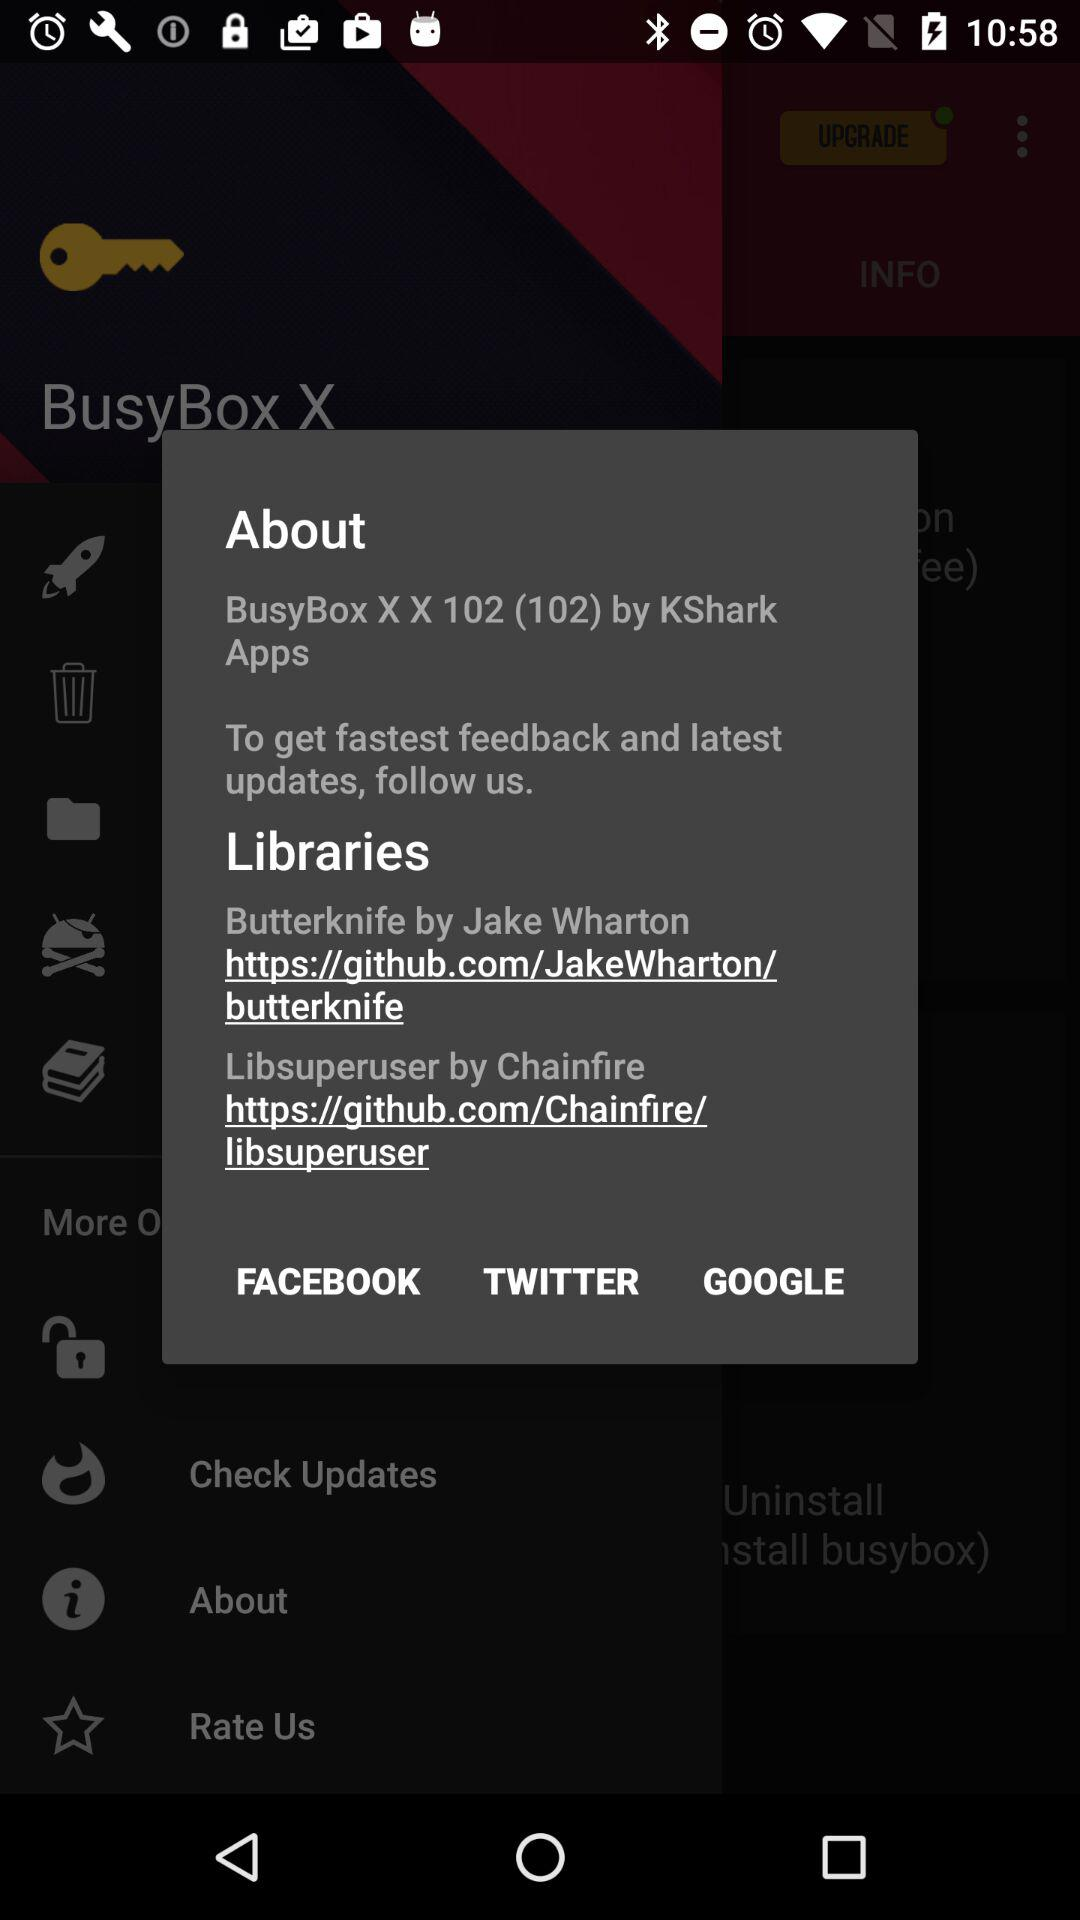Which are the different following options?
When the provided information is insufficient, respond with <no answer>. <no answer> 